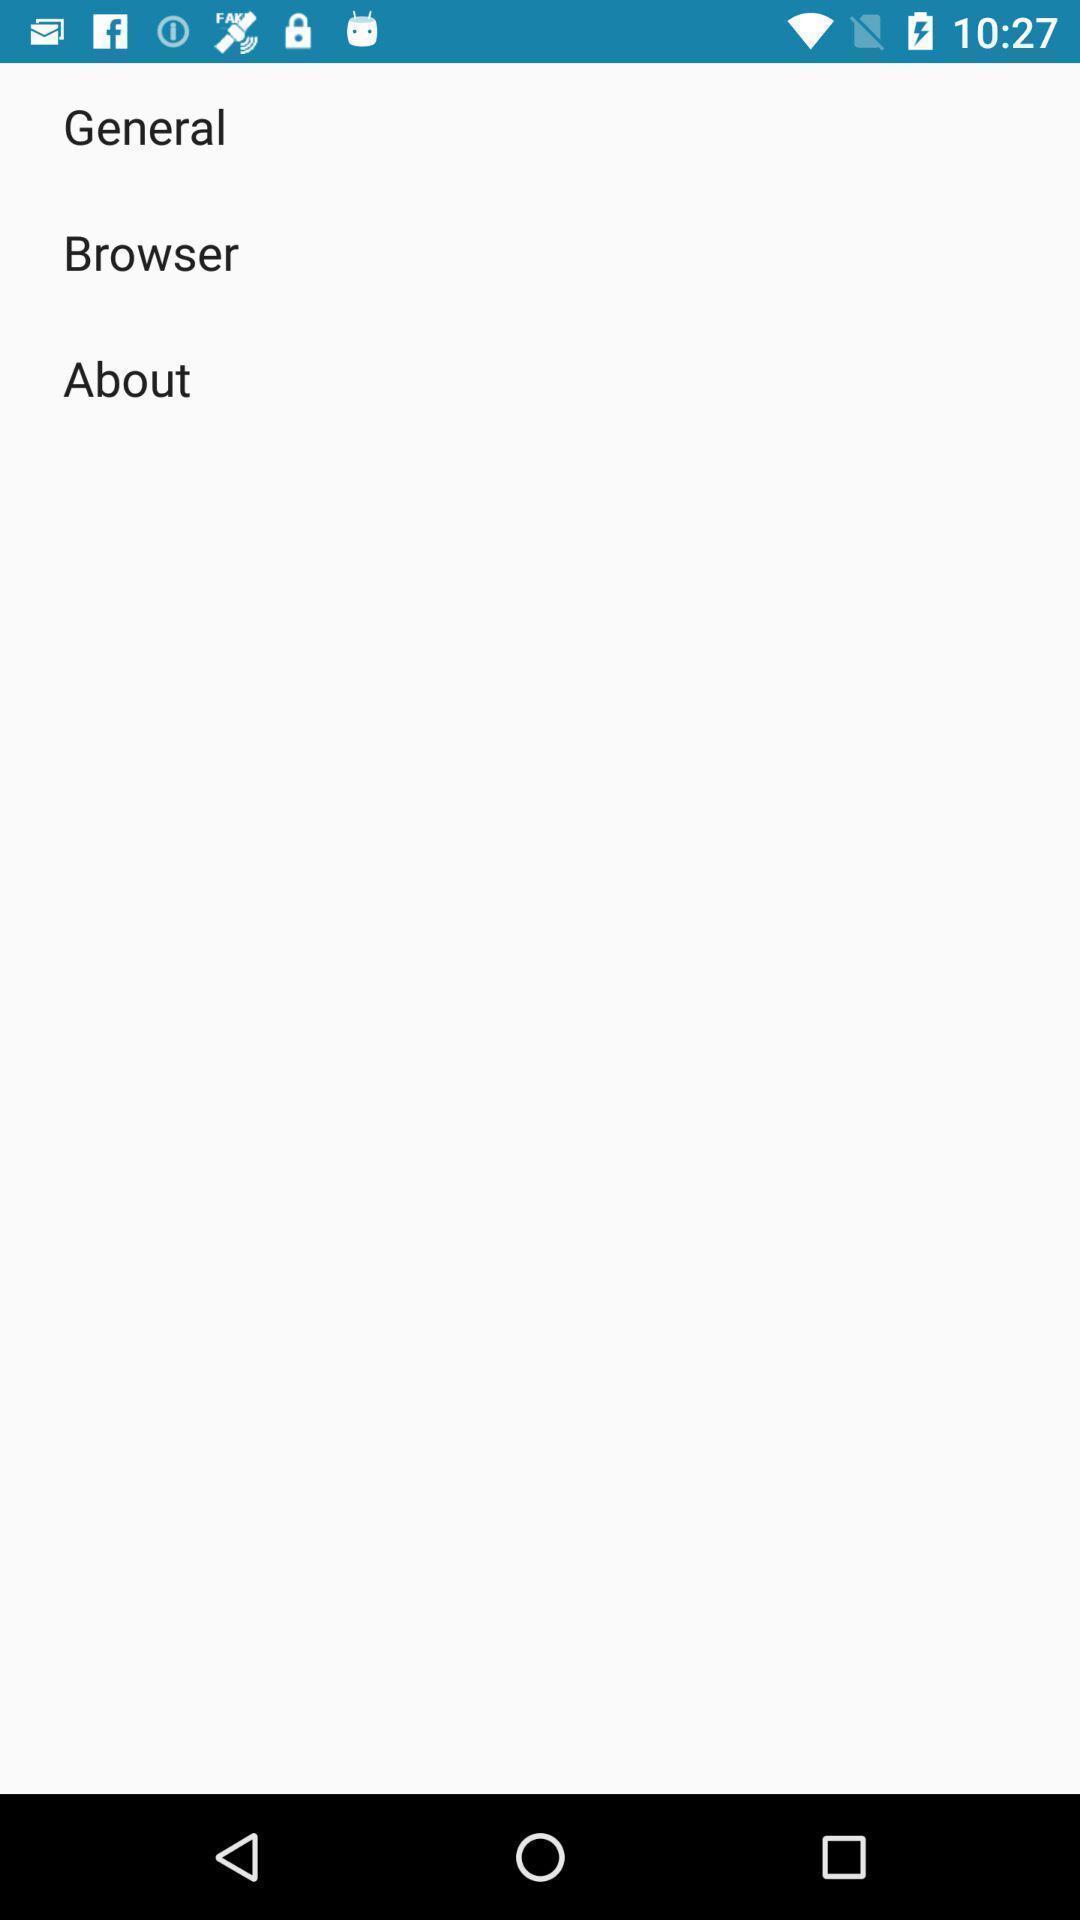Summarize the information in this screenshot. Screen displaying general settings on a device. 